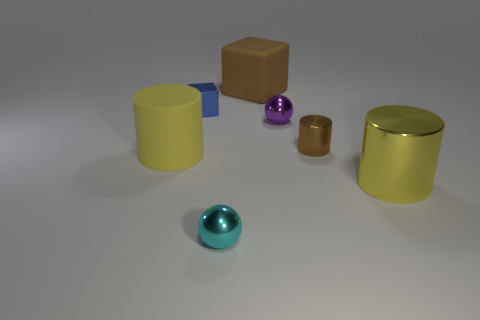Add 1 big brown rubber objects. How many objects exist? 8 Subtract all balls. How many objects are left? 5 Subtract all big cyan objects. Subtract all brown cylinders. How many objects are left? 6 Add 4 purple balls. How many purple balls are left? 5 Add 2 large gray metallic spheres. How many large gray metallic spheres exist? 2 Subtract 0 blue spheres. How many objects are left? 7 